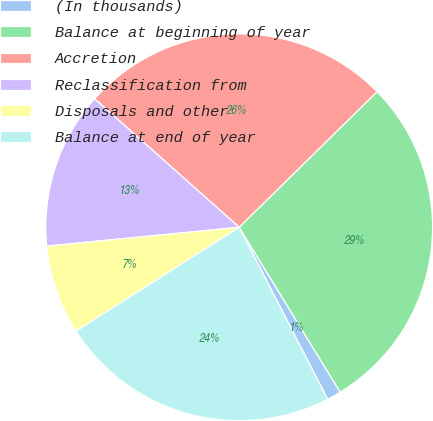<chart> <loc_0><loc_0><loc_500><loc_500><pie_chart><fcel>(In thousands)<fcel>Balance at beginning of year<fcel>Accretion<fcel>Reclassification from<fcel>Disposals and other<fcel>Balance at end of year<nl><fcel>1.19%<fcel>28.62%<fcel>26.07%<fcel>13.12%<fcel>7.47%<fcel>23.53%<nl></chart> 